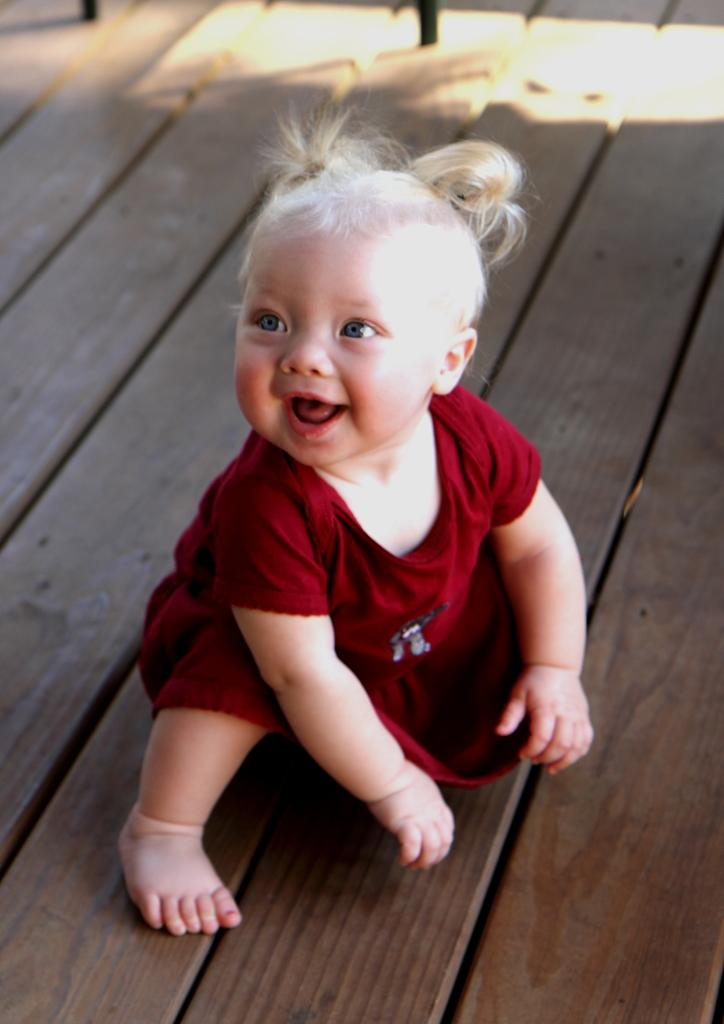Who is the main subject in the image? There is a baby girl in the image. What is the baby girl standing on? The baby girl is on a wooden platform. How much profit does the baby girl make from the sticks in the image? There are no sticks or any indication of profit-making activities in the image. 